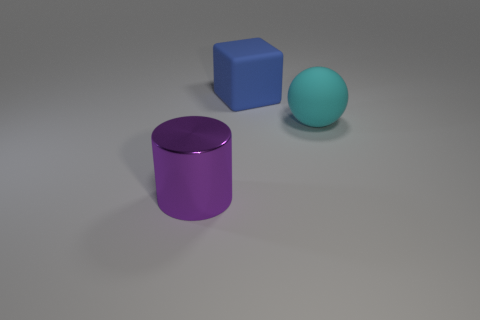Add 3 brown matte spheres. How many objects exist? 6 Subtract all cubes. How many objects are left? 2 Add 1 big purple metal things. How many big purple metal things exist? 2 Subtract 0 blue cylinders. How many objects are left? 3 Subtract all cyan objects. Subtract all big cyan objects. How many objects are left? 1 Add 3 cylinders. How many cylinders are left? 4 